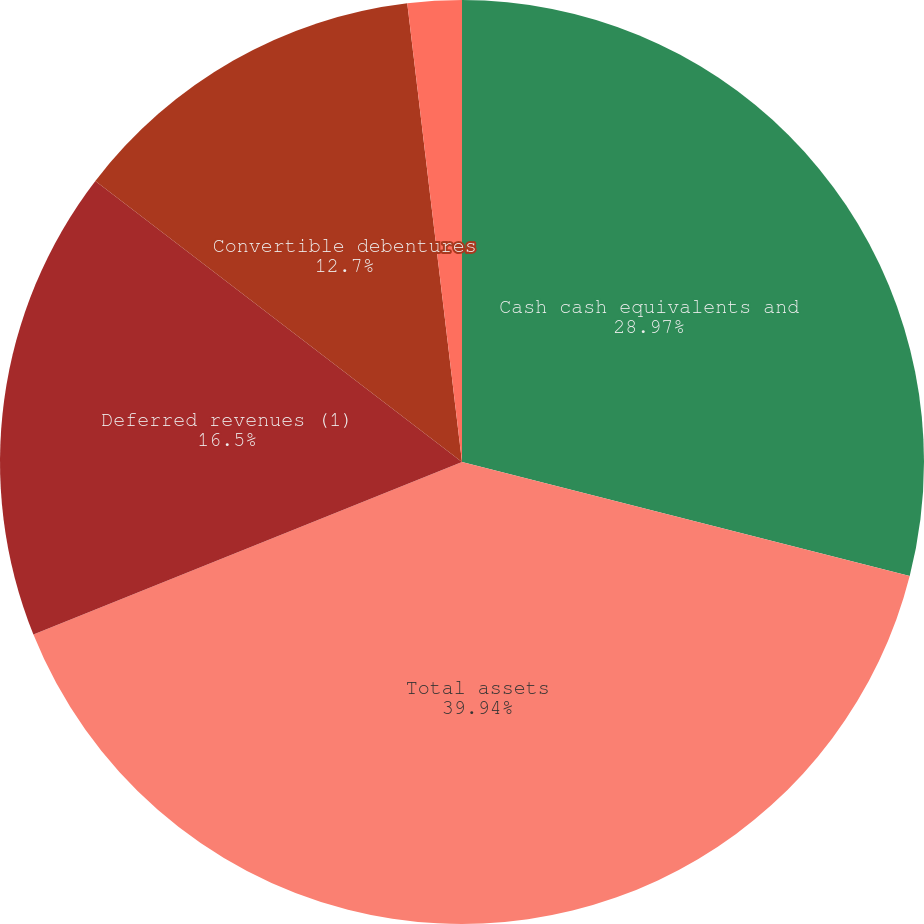Convert chart to OTSL. <chart><loc_0><loc_0><loc_500><loc_500><pie_chart><fcel>Cash cash equivalents and<fcel>Total assets<fcel>Deferred revenues (1)<fcel>Convertible debentures<fcel>Stockholders' (deficit) equity<nl><fcel>28.97%<fcel>39.94%<fcel>16.5%<fcel>12.7%<fcel>1.89%<nl></chart> 